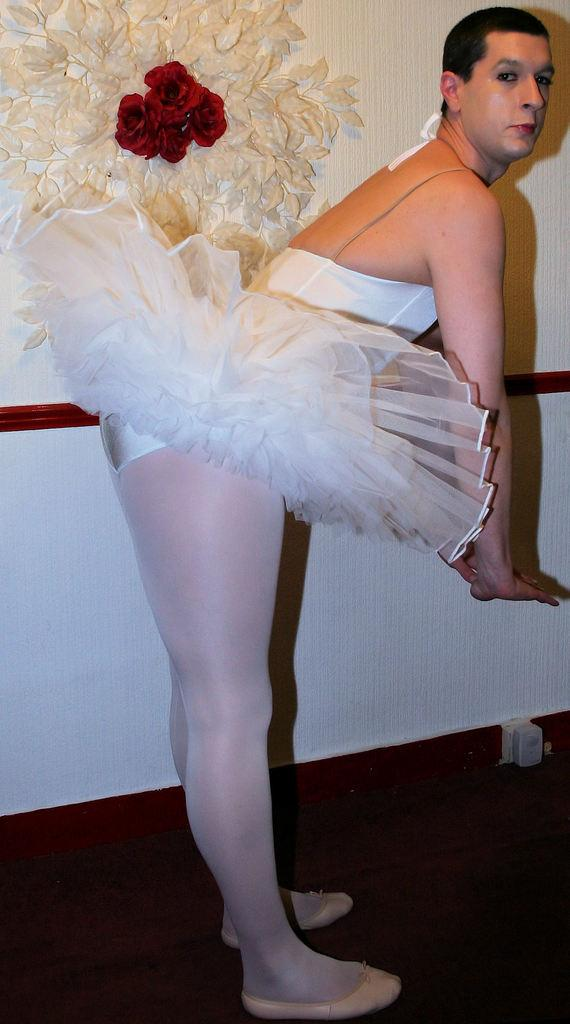Who or what is the main subject in the image? There is a person in the image. Can you describe what the person is wearing? The person is wearing a frock. What can be seen in the background of the image? There is a wall in the background of the image. What is special about the wall? The wall has flowers on it and there are decorative things on the wall. What type of authority does the person in the image have over the industry? There is no mention of authority or industry in the image, so it is not possible to answer that question. 